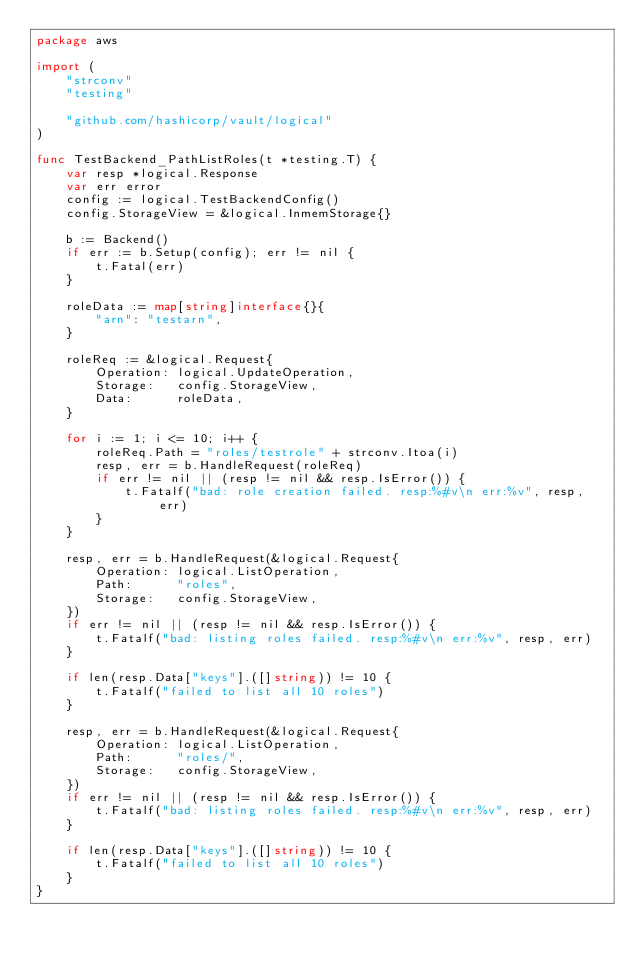<code> <loc_0><loc_0><loc_500><loc_500><_Go_>package aws

import (
	"strconv"
	"testing"

	"github.com/hashicorp/vault/logical"
)

func TestBackend_PathListRoles(t *testing.T) {
	var resp *logical.Response
	var err error
	config := logical.TestBackendConfig()
	config.StorageView = &logical.InmemStorage{}

	b := Backend()
	if err := b.Setup(config); err != nil {
		t.Fatal(err)
	}

	roleData := map[string]interface{}{
		"arn": "testarn",
	}

	roleReq := &logical.Request{
		Operation: logical.UpdateOperation,
		Storage:   config.StorageView,
		Data:      roleData,
	}

	for i := 1; i <= 10; i++ {
		roleReq.Path = "roles/testrole" + strconv.Itoa(i)
		resp, err = b.HandleRequest(roleReq)
		if err != nil || (resp != nil && resp.IsError()) {
			t.Fatalf("bad: role creation failed. resp:%#v\n err:%v", resp, err)
		}
	}

	resp, err = b.HandleRequest(&logical.Request{
		Operation: logical.ListOperation,
		Path:      "roles",
		Storage:   config.StorageView,
	})
	if err != nil || (resp != nil && resp.IsError()) {
		t.Fatalf("bad: listing roles failed. resp:%#v\n err:%v", resp, err)
	}

	if len(resp.Data["keys"].([]string)) != 10 {
		t.Fatalf("failed to list all 10 roles")
	}

	resp, err = b.HandleRequest(&logical.Request{
		Operation: logical.ListOperation,
		Path:      "roles/",
		Storage:   config.StorageView,
	})
	if err != nil || (resp != nil && resp.IsError()) {
		t.Fatalf("bad: listing roles failed. resp:%#v\n err:%v", resp, err)
	}

	if len(resp.Data["keys"].([]string)) != 10 {
		t.Fatalf("failed to list all 10 roles")
	}
}
</code> 